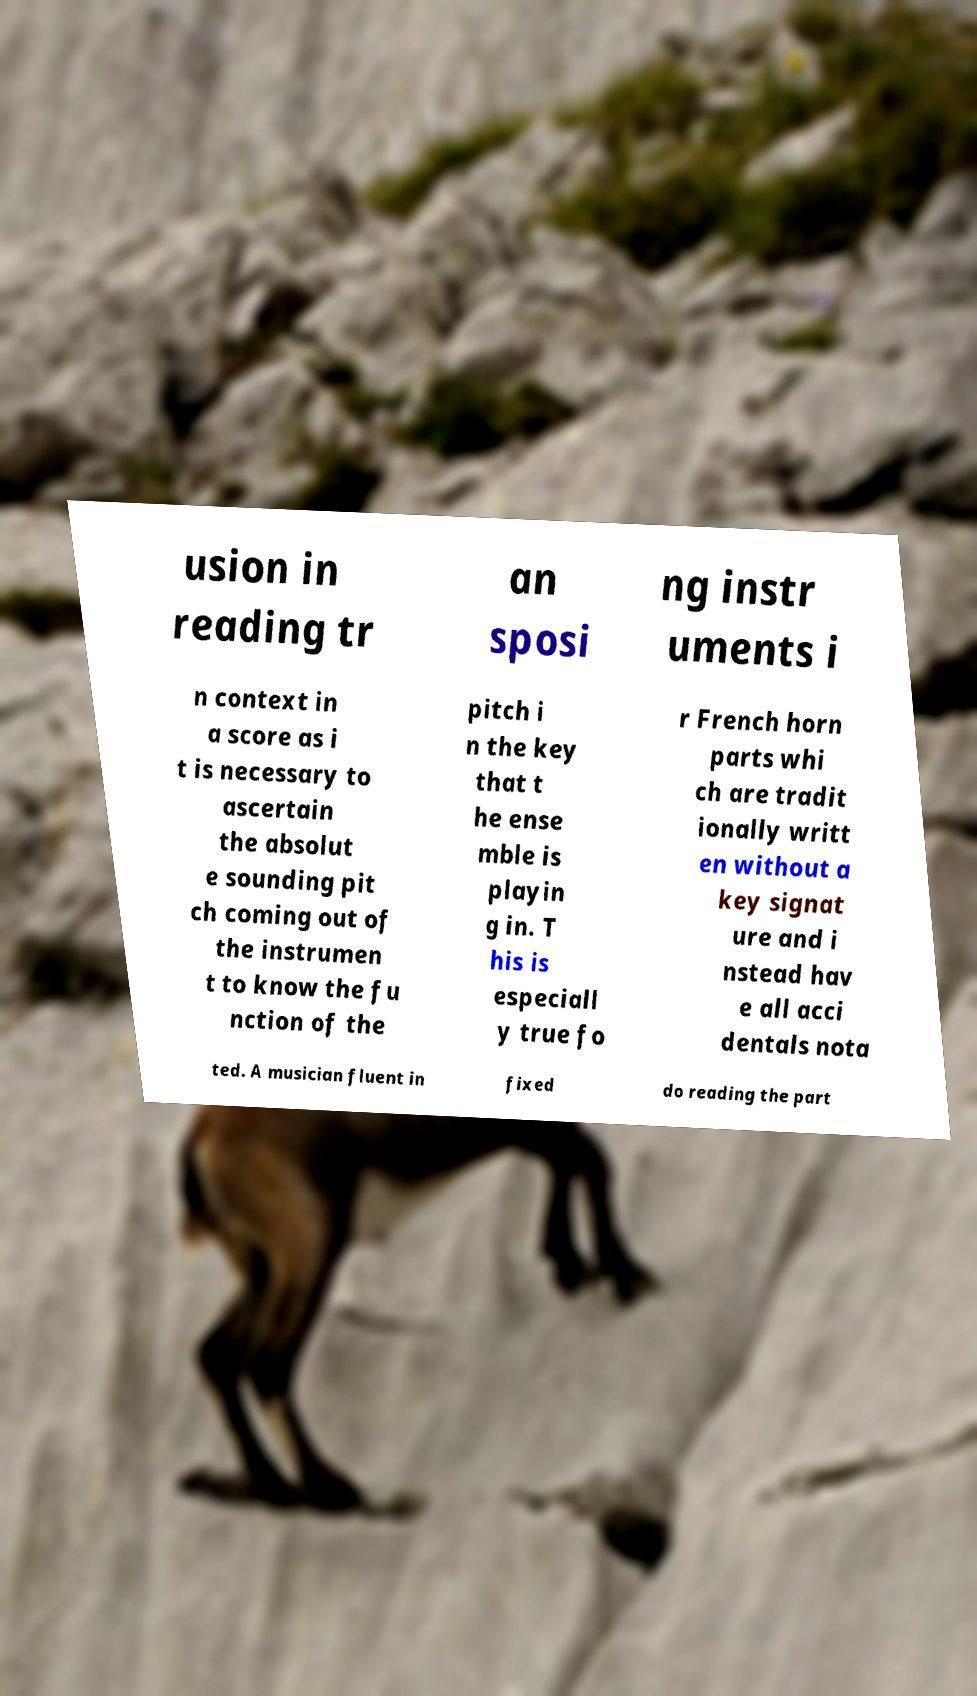I need the written content from this picture converted into text. Can you do that? usion in reading tr an sposi ng instr uments i n context in a score as i t is necessary to ascertain the absolut e sounding pit ch coming out of the instrumen t to know the fu nction of the pitch i n the key that t he ense mble is playin g in. T his is especiall y true fo r French horn parts whi ch are tradit ionally writt en without a key signat ure and i nstead hav e all acci dentals nota ted. A musician fluent in fixed do reading the part 